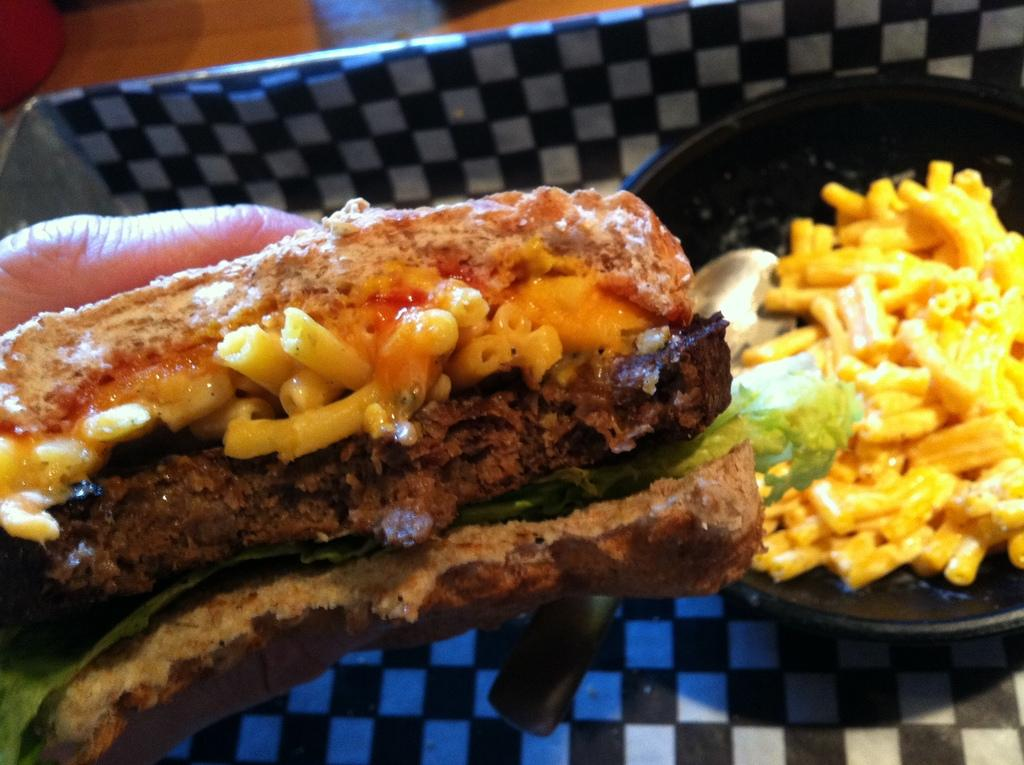What is the person in the image holding? The person is holding a food item in the image. What is the food item being prepared in? The food item is in a pan in the image. What is located beside the pan? There is a tray beside the pan in the image. What object can be seen on the table in the image? There is an object on the table in the image. What type of music is being played in the background of the image? There is no indication of music being played in the image. 